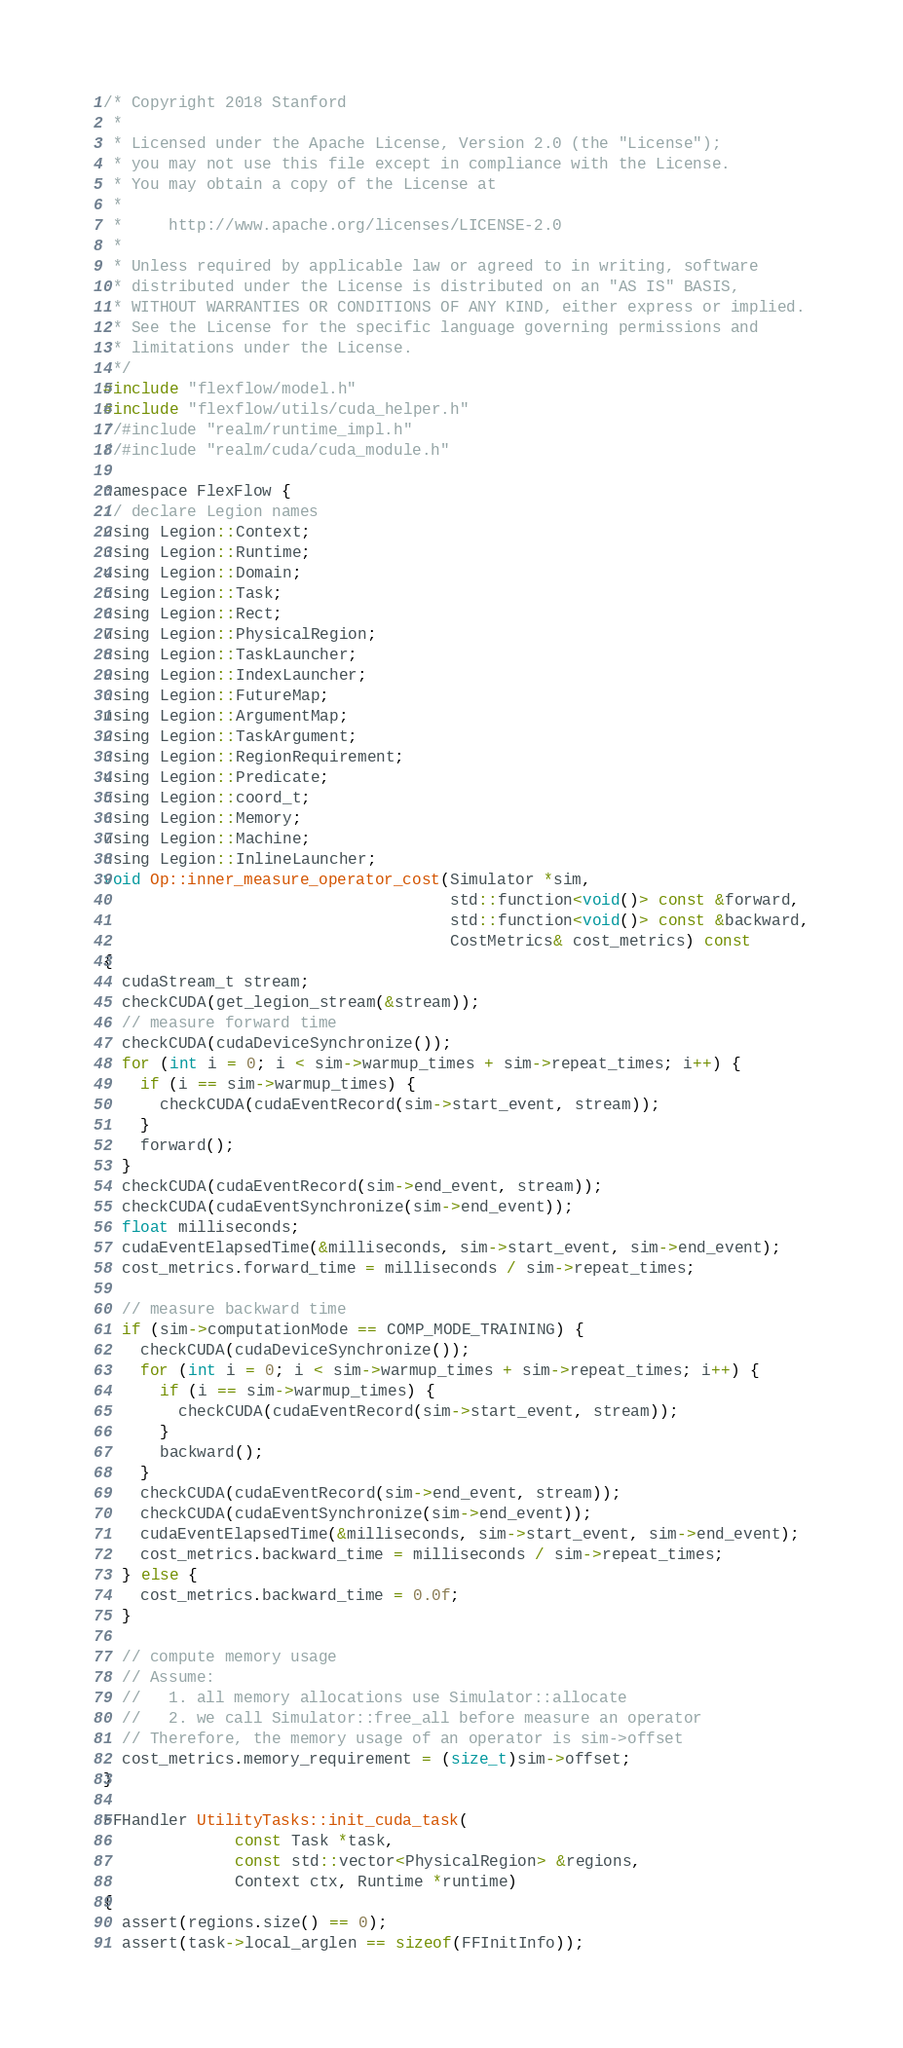Convert code to text. <code><loc_0><loc_0><loc_500><loc_500><_Cuda_>/* Copyright 2018 Stanford
 *
 * Licensed under the Apache License, Version 2.0 (the "License");
 * you may not use this file except in compliance with the License.
 * You may obtain a copy of the License at
 *
 *     http://www.apache.org/licenses/LICENSE-2.0
 *
 * Unless required by applicable law or agreed to in writing, software
 * distributed under the License is distributed on an "AS IS" BASIS,
 * WITHOUT WARRANTIES OR CONDITIONS OF ANY KIND, either express or implied.
 * See the License for the specific language governing permissions and
 * limitations under the License.
 */
#include "flexflow/model.h"
#include "flexflow/utils/cuda_helper.h"
//#include "realm/runtime_impl.h"
//#include "realm/cuda/cuda_module.h"

namespace FlexFlow {
// declare Legion names
using Legion::Context;
using Legion::Runtime;
using Legion::Domain;
using Legion::Task;
using Legion::Rect;
using Legion::PhysicalRegion;
using Legion::TaskLauncher;
using Legion::IndexLauncher;
using Legion::FutureMap;
using Legion::ArgumentMap;
using Legion::TaskArgument;
using Legion::RegionRequirement;
using Legion::Predicate;
using Legion::coord_t;
using Legion::Memory;
using Legion::Machine;
using Legion::InlineLauncher;
void Op::inner_measure_operator_cost(Simulator *sim,
                                     std::function<void()> const &forward,
                                     std::function<void()> const &backward,
                                     CostMetrics& cost_metrics) const
{
  cudaStream_t stream;
  checkCUDA(get_legion_stream(&stream));
  // measure forward time
  checkCUDA(cudaDeviceSynchronize());
  for (int i = 0; i < sim->warmup_times + sim->repeat_times; i++) {
    if (i == sim->warmup_times) {
      checkCUDA(cudaEventRecord(sim->start_event, stream));
    }
    forward();
  }
  checkCUDA(cudaEventRecord(sim->end_event, stream));
  checkCUDA(cudaEventSynchronize(sim->end_event));
  float milliseconds;
  cudaEventElapsedTime(&milliseconds, sim->start_event, sim->end_event);
  cost_metrics.forward_time = milliseconds / sim->repeat_times;

  // measure backward time
  if (sim->computationMode == COMP_MODE_TRAINING) {
    checkCUDA(cudaDeviceSynchronize());
    for (int i = 0; i < sim->warmup_times + sim->repeat_times; i++) {
      if (i == sim->warmup_times) {
        checkCUDA(cudaEventRecord(sim->start_event, stream));
      }
      backward();
    }
    checkCUDA(cudaEventRecord(sim->end_event, stream));
    checkCUDA(cudaEventSynchronize(sim->end_event));
    cudaEventElapsedTime(&milliseconds, sim->start_event, sim->end_event);
    cost_metrics.backward_time = milliseconds / sim->repeat_times;
  } else {
    cost_metrics.backward_time = 0.0f;
  }

  // compute memory usage
  // Assume:
  //   1. all memory allocations use Simulator::allocate
  //   2. we call Simulator::free_all before measure an operator
  // Therefore, the memory usage of an operator is sim->offset
  cost_metrics.memory_requirement = (size_t)sim->offset;
}

FFHandler UtilityTasks::init_cuda_task(
              const Task *task,
              const std::vector<PhysicalRegion> &regions,
              Context ctx, Runtime *runtime)
{
  assert(regions.size() == 0);
  assert(task->local_arglen == sizeof(FFInitInfo));</code> 